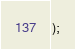Convert code to text. <code><loc_0><loc_0><loc_500><loc_500><_TypeScript_>);
</code> 